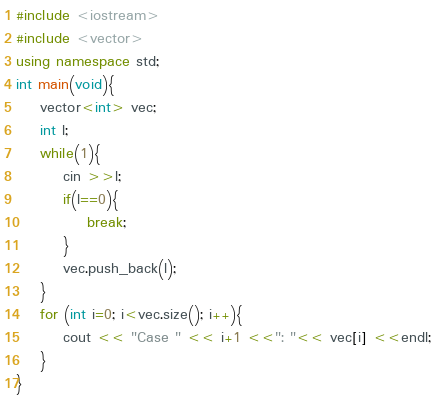<code> <loc_0><loc_0><loc_500><loc_500><_C++_>#include <iostream>
#include <vector> 
using namespace std;
int main(void){
    vector<int> vec;
    int l;
    while(1){
        cin >>l;
        if(l==0){
            break;
        }
        vec.push_back(l);
    }
    for (int i=0; i<vec.size(); i++){
        cout << "Case " << i+1 <<": "<< vec[i] <<endl;
    }
}
</code> 